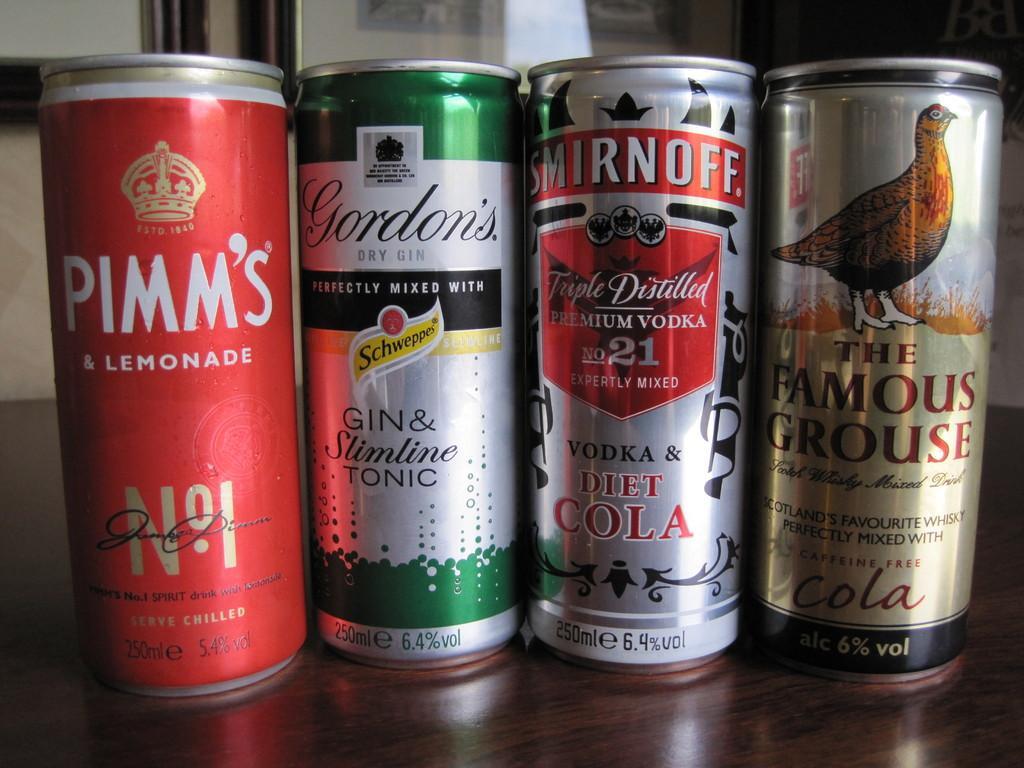Could you give a brief overview of what you see in this image? In this image we can see four things on a platform. On the things we can see picture of a bird and something is written on it. 